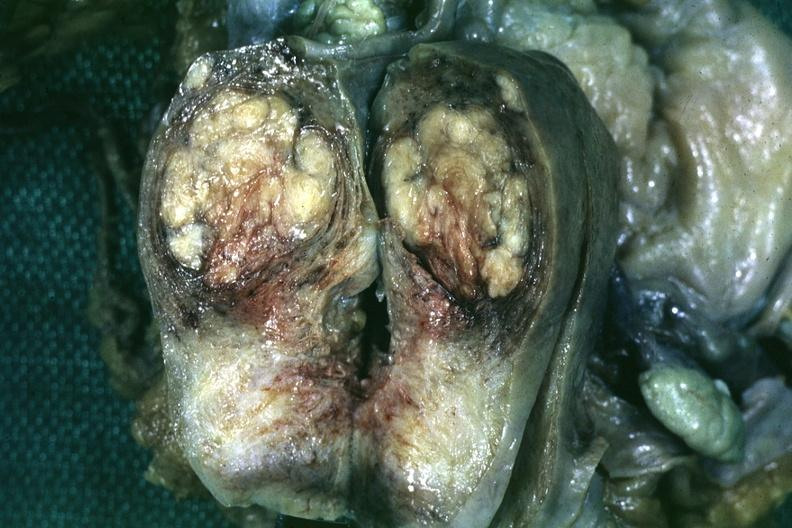what does this image show?
Answer the question using a single word or phrase. Fixed tissue saggital section of organ with bosselated myoma 